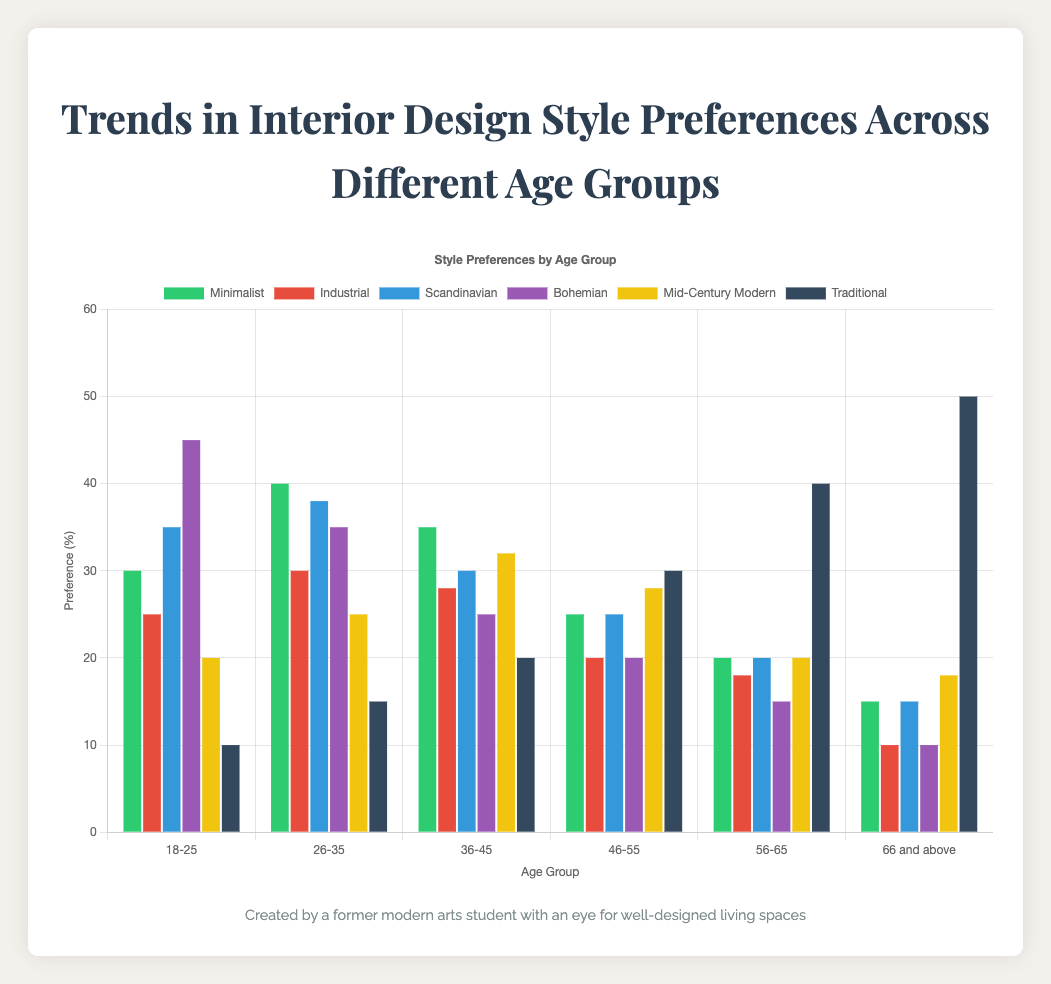What age group has the highest preference for Traditional style? The dataset shows that the preference for Traditional style increases with age, reaching its peak in the last age group. The '66 and above' age group has the highest bar, indicating the highest preference for Traditional style.
Answer: 66 and above Which style does the 18-25 age group prefer the most? Refer to the bar heights within the '18-25' age group. The Bohemian style has the tallest bar, meaning it is the most preferred style in this age group.
Answer: Bohemian Compare the preference for Minimalist style between the 26-35 and 36-45 age groups. Look at the bars for the Minimalist style in the two age groups. The '26-35' has a taller bar (40) compared to the '36-45' group (35), indicating a higher preference.
Answer: 26-35 Which style preference declines the most from the 18-25 to the 66 and above age groups? Compare the differences in preference for each style from '18-25' to '66 and above'. The Bohemian style drops from 45% to 10%, showing the most significant decline.
Answer: Bohemian What is the average preference for Industrial style across all age groups? Add the percentages for Industrial style across all age groups (25 + 30 + 28 + 20 + 18 + 10) = 131. Then, divide by the number of age groups (6) to find the average: 131/6 ≈ 21.83%
Answer: 21.83% In the 46-55 age group, which style has the closest preference to the Mid-Century Modern style? In the '46-55' age group, compare the preferences for styles to the Mid-Century Modern (28%). The closest value to 28% is Traditional, which is 30%.
Answer: Traditional How does the preference for Scandinavian style change from the 18-25 to 56-65 age groups? Look at the Scandinavian style preferences for these age groups. It starts at 35% for '18-25' and decreases progressively to 20% for '56-65'.
Answer: Decreases by 15% Which two styles have almost equal preferences in the 36-45 age group? In the '36-45' group, compare the preferences for all styles. The closest preferences are Bohemian (25%) and Industrial (28%).
Answer: Bohemian and Industrial What is the total preference for the Minimalist style across all age groups? Sum the preferences for Minimalist style across all age groups (30 + 40 + 35 + 25 + 20 + 15): 165.
Answer: 165 Which age group shows the least variance in style preferences? Analyze the differences in heights of bars within each age group. The '56-65' group has relatively small differences among its styles, showing the least variance.
Answer: 56-65 